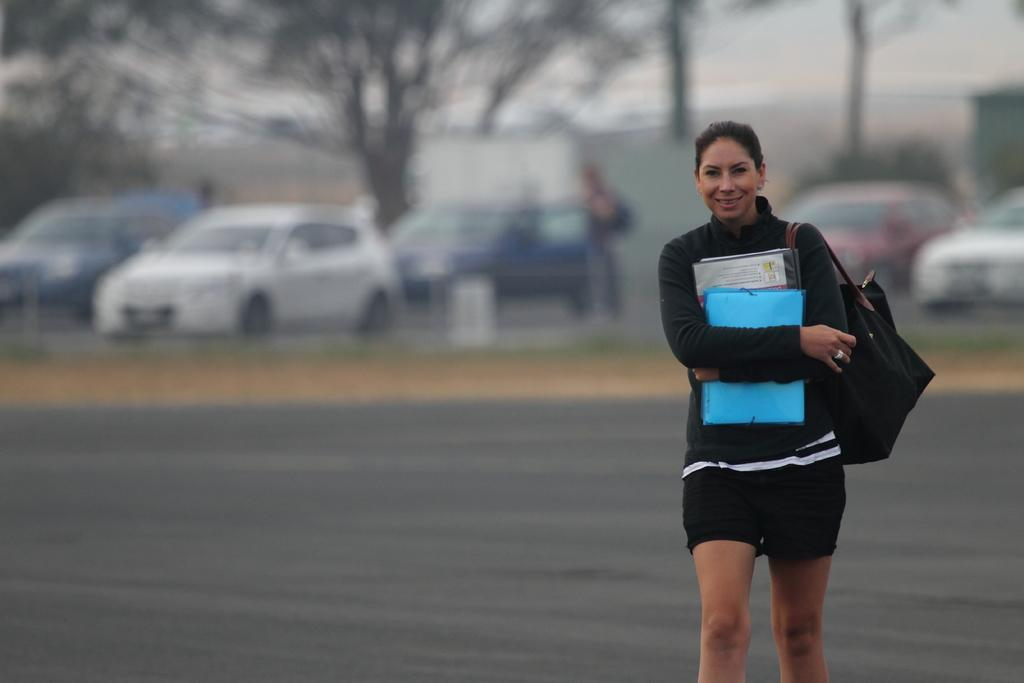Who is the main subject in the image? There is a lady in the image. What is the lady wearing? The lady is wearing a bag. What is the lady holding in her hands? The lady is holding books in her hands. What is the lady doing in the image? The lady is walking on a road. What can be seen in the background of the image? There are cars and trees in the background of the image. How is the background of the image depicted? The background is blurred. What type of theory is the lady discussing with the baseball player in the image? There is no baseball player or discussion of a theory in the image; it features a lady walking on a road while holding books. 